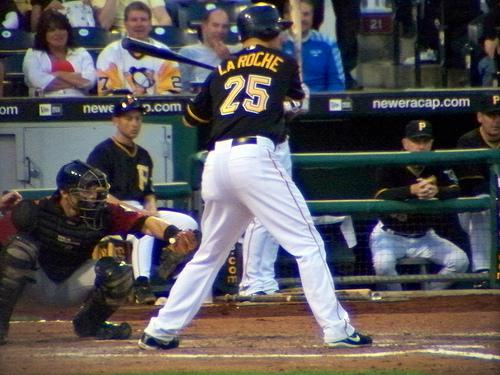Question: what sport is being played?
Choices:
A. Soccer.
B. Football.
C. Bowling.
D. Baseball.
Answer with the letter. Answer: D Question: what brand of shoes is La Roche wearing?
Choices:
A. Gucci.
B. The store's brand.
C. Nun Bush.
D. Nike.
Answer with the letter. Answer: D Question: why is La Roche holding a bat?
Choices:
A. He is defending himself.
B. He is warming up.
C. He is batting.
D. He is teaching others.
Answer with the letter. Answer: C Question: when do baseball player's hold a bat at homeplate?
Choices:
A. When training.
B. When warming up.
C. Before hitting the ball.
D. When batting.
Answer with the letter. Answer: D 